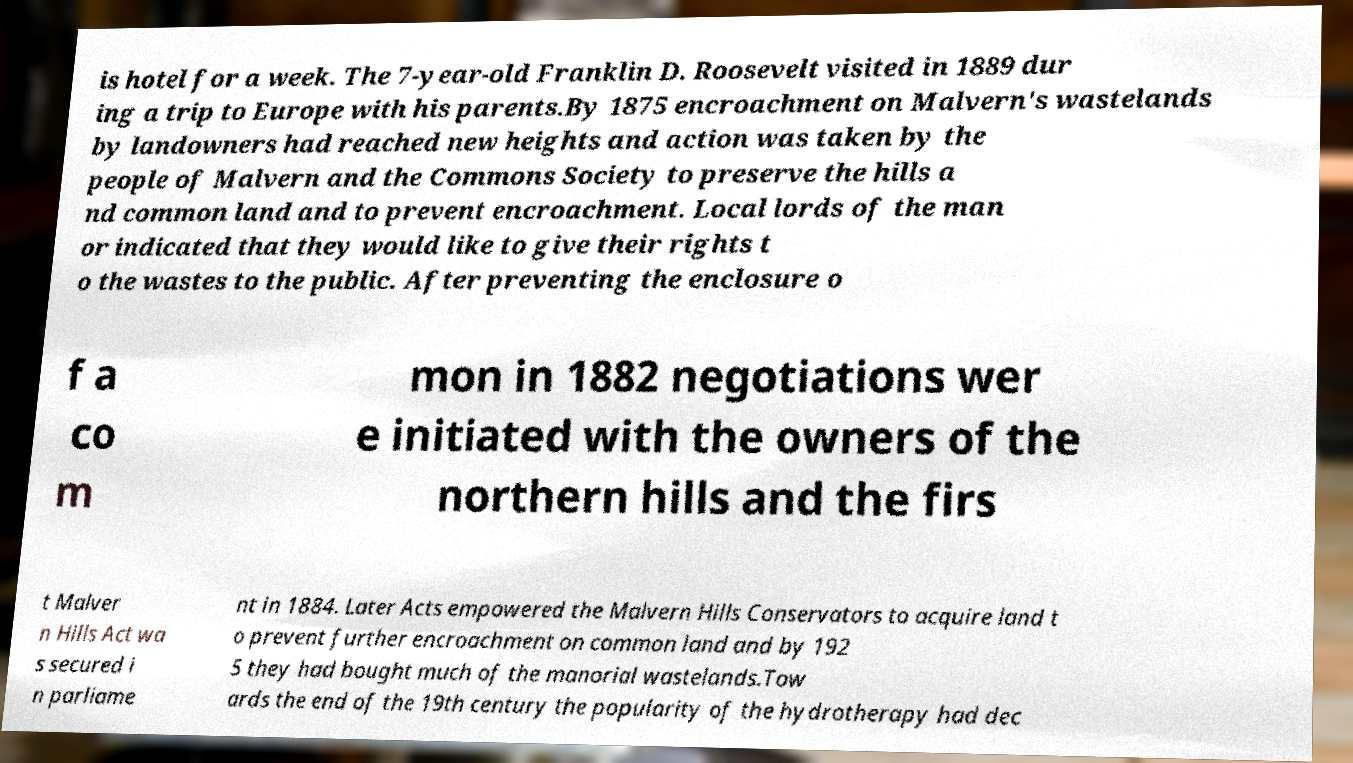Could you extract and type out the text from this image? is hotel for a week. The 7-year-old Franklin D. Roosevelt visited in 1889 dur ing a trip to Europe with his parents.By 1875 encroachment on Malvern's wastelands by landowners had reached new heights and action was taken by the people of Malvern and the Commons Society to preserve the hills a nd common land and to prevent encroachment. Local lords of the man or indicated that they would like to give their rights t o the wastes to the public. After preventing the enclosure o f a co m mon in 1882 negotiations wer e initiated with the owners of the northern hills and the firs t Malver n Hills Act wa s secured i n parliame nt in 1884. Later Acts empowered the Malvern Hills Conservators to acquire land t o prevent further encroachment on common land and by 192 5 they had bought much of the manorial wastelands.Tow ards the end of the 19th century the popularity of the hydrotherapy had dec 